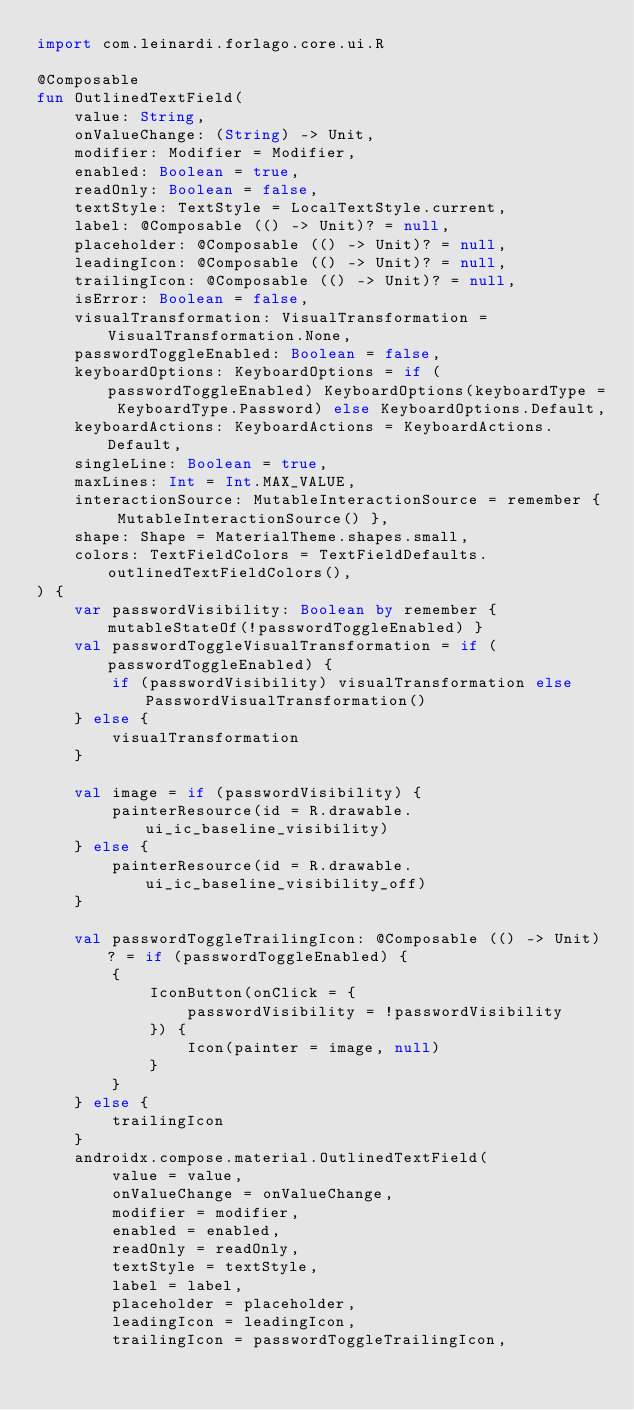<code> <loc_0><loc_0><loc_500><loc_500><_Kotlin_>import com.leinardi.forlago.core.ui.R

@Composable
fun OutlinedTextField(
    value: String,
    onValueChange: (String) -> Unit,
    modifier: Modifier = Modifier,
    enabled: Boolean = true,
    readOnly: Boolean = false,
    textStyle: TextStyle = LocalTextStyle.current,
    label: @Composable (() -> Unit)? = null,
    placeholder: @Composable (() -> Unit)? = null,
    leadingIcon: @Composable (() -> Unit)? = null,
    trailingIcon: @Composable (() -> Unit)? = null,
    isError: Boolean = false,
    visualTransformation: VisualTransformation = VisualTransformation.None,
    passwordToggleEnabled: Boolean = false,
    keyboardOptions: KeyboardOptions = if (passwordToggleEnabled) KeyboardOptions(keyboardType = KeyboardType.Password) else KeyboardOptions.Default,
    keyboardActions: KeyboardActions = KeyboardActions.Default,
    singleLine: Boolean = true,
    maxLines: Int = Int.MAX_VALUE,
    interactionSource: MutableInteractionSource = remember { MutableInteractionSource() },
    shape: Shape = MaterialTheme.shapes.small,
    colors: TextFieldColors = TextFieldDefaults.outlinedTextFieldColors(),
) {
    var passwordVisibility: Boolean by remember { mutableStateOf(!passwordToggleEnabled) }
    val passwordToggleVisualTransformation = if (passwordToggleEnabled) {
        if (passwordVisibility) visualTransformation else PasswordVisualTransformation()
    } else {
        visualTransformation
    }

    val image = if (passwordVisibility) {
        painterResource(id = R.drawable.ui_ic_baseline_visibility)
    } else {
        painterResource(id = R.drawable.ui_ic_baseline_visibility_off)
    }

    val passwordToggleTrailingIcon: @Composable (() -> Unit)? = if (passwordToggleEnabled) {
        {
            IconButton(onClick = {
                passwordVisibility = !passwordVisibility
            }) {
                Icon(painter = image, null)
            }
        }
    } else {
        trailingIcon
    }
    androidx.compose.material.OutlinedTextField(
        value = value,
        onValueChange = onValueChange,
        modifier = modifier,
        enabled = enabled,
        readOnly = readOnly,
        textStyle = textStyle,
        label = label,
        placeholder = placeholder,
        leadingIcon = leadingIcon,
        trailingIcon = passwordToggleTrailingIcon,</code> 